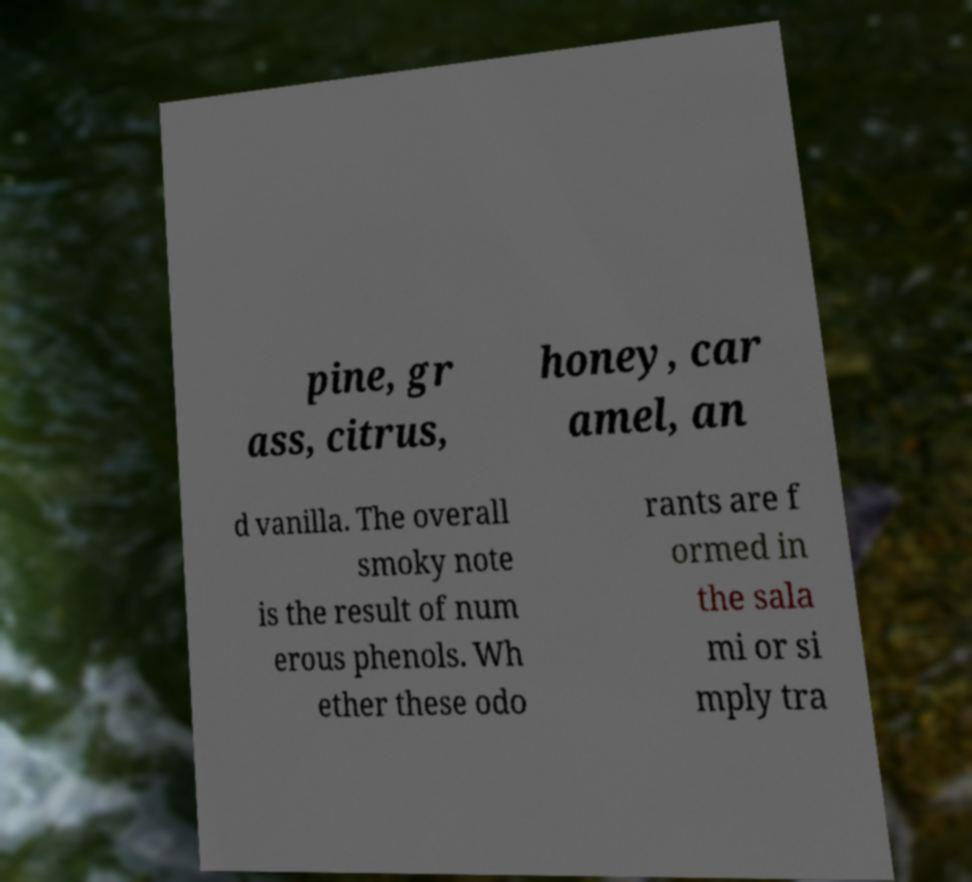Could you assist in decoding the text presented in this image and type it out clearly? pine, gr ass, citrus, honey, car amel, an d vanilla. The overall smoky note is the result of num erous phenols. Wh ether these odo rants are f ormed in the sala mi or si mply tra 